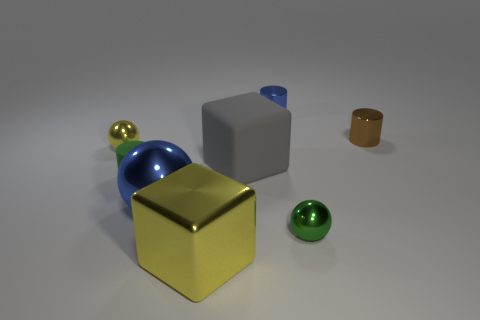Does the big yellow metallic object have the same shape as the thing behind the small brown object?
Your answer should be compact. No. How many other things are there of the same size as the brown cylinder?
Your answer should be compact. 4. What number of blue things are either cylinders or tiny shiny cylinders?
Offer a terse response. 1. How many shiny things are behind the green shiny sphere and on the left side of the small blue metallic cylinder?
Provide a succinct answer. 2. What is the material of the blue sphere that is right of the green rubber thing to the left of the yellow metallic object in front of the yellow ball?
Offer a very short reply. Metal. What number of blocks have the same material as the small yellow sphere?
Give a very brief answer. 1. What is the shape of the tiny metal thing that is the same color as the large metal cube?
Offer a very short reply. Sphere. What shape is the green rubber thing that is the same size as the yellow metal ball?
Provide a short and direct response. Cylinder. There is a tiny thing that is the same color as the big sphere; what is its material?
Provide a short and direct response. Metal. Are there any metal cubes behind the tiny yellow metallic thing?
Your answer should be very brief. No. 